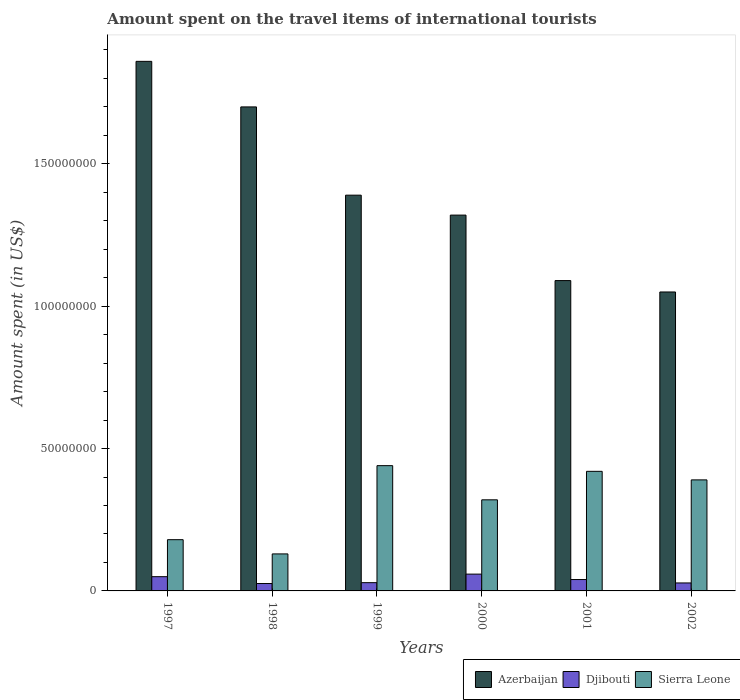How many groups of bars are there?
Your answer should be very brief. 6. How many bars are there on the 4th tick from the right?
Your answer should be very brief. 3. In how many cases, is the number of bars for a given year not equal to the number of legend labels?
Keep it short and to the point. 0. What is the amount spent on the travel items of international tourists in Sierra Leone in 1998?
Offer a terse response. 1.30e+07. Across all years, what is the maximum amount spent on the travel items of international tourists in Azerbaijan?
Offer a very short reply. 1.86e+08. Across all years, what is the minimum amount spent on the travel items of international tourists in Djibouti?
Offer a very short reply. 2.60e+06. In which year was the amount spent on the travel items of international tourists in Azerbaijan maximum?
Give a very brief answer. 1997. What is the total amount spent on the travel items of international tourists in Djibouti in the graph?
Provide a succinct answer. 2.32e+07. What is the difference between the amount spent on the travel items of international tourists in Sierra Leone in 1998 and that in 2000?
Keep it short and to the point. -1.90e+07. What is the difference between the amount spent on the travel items of international tourists in Djibouti in 2000 and the amount spent on the travel items of international tourists in Sierra Leone in 2001?
Your answer should be compact. -3.61e+07. What is the average amount spent on the travel items of international tourists in Djibouti per year?
Your answer should be compact. 3.87e+06. In the year 2002, what is the difference between the amount spent on the travel items of international tourists in Azerbaijan and amount spent on the travel items of international tourists in Djibouti?
Provide a short and direct response. 1.02e+08. What is the ratio of the amount spent on the travel items of international tourists in Djibouti in 1999 to that in 2000?
Give a very brief answer. 0.49. Is the amount spent on the travel items of international tourists in Sierra Leone in 1998 less than that in 2001?
Offer a very short reply. Yes. Is the difference between the amount spent on the travel items of international tourists in Azerbaijan in 1997 and 2000 greater than the difference between the amount spent on the travel items of international tourists in Djibouti in 1997 and 2000?
Ensure brevity in your answer.  Yes. What is the difference between the highest and the second highest amount spent on the travel items of international tourists in Azerbaijan?
Provide a short and direct response. 1.60e+07. What is the difference between the highest and the lowest amount spent on the travel items of international tourists in Azerbaijan?
Offer a terse response. 8.10e+07. In how many years, is the amount spent on the travel items of international tourists in Azerbaijan greater than the average amount spent on the travel items of international tourists in Azerbaijan taken over all years?
Your answer should be very brief. 2. Is the sum of the amount spent on the travel items of international tourists in Azerbaijan in 1998 and 2000 greater than the maximum amount spent on the travel items of international tourists in Djibouti across all years?
Provide a succinct answer. Yes. What does the 1st bar from the left in 2000 represents?
Your response must be concise. Azerbaijan. What does the 1st bar from the right in 2000 represents?
Give a very brief answer. Sierra Leone. Is it the case that in every year, the sum of the amount spent on the travel items of international tourists in Azerbaijan and amount spent on the travel items of international tourists in Djibouti is greater than the amount spent on the travel items of international tourists in Sierra Leone?
Ensure brevity in your answer.  Yes. How many bars are there?
Make the answer very short. 18. How many years are there in the graph?
Provide a succinct answer. 6. What is the difference between two consecutive major ticks on the Y-axis?
Provide a succinct answer. 5.00e+07. Are the values on the major ticks of Y-axis written in scientific E-notation?
Offer a terse response. No. Does the graph contain any zero values?
Keep it short and to the point. No. Where does the legend appear in the graph?
Provide a short and direct response. Bottom right. What is the title of the graph?
Your answer should be compact. Amount spent on the travel items of international tourists. Does "Denmark" appear as one of the legend labels in the graph?
Your response must be concise. No. What is the label or title of the X-axis?
Provide a short and direct response. Years. What is the label or title of the Y-axis?
Your answer should be compact. Amount spent (in US$). What is the Amount spent (in US$) of Azerbaijan in 1997?
Your answer should be compact. 1.86e+08. What is the Amount spent (in US$) of Djibouti in 1997?
Provide a short and direct response. 5.00e+06. What is the Amount spent (in US$) of Sierra Leone in 1997?
Keep it short and to the point. 1.80e+07. What is the Amount spent (in US$) in Azerbaijan in 1998?
Keep it short and to the point. 1.70e+08. What is the Amount spent (in US$) of Djibouti in 1998?
Your answer should be very brief. 2.60e+06. What is the Amount spent (in US$) in Sierra Leone in 1998?
Ensure brevity in your answer.  1.30e+07. What is the Amount spent (in US$) in Azerbaijan in 1999?
Provide a succinct answer. 1.39e+08. What is the Amount spent (in US$) of Djibouti in 1999?
Offer a terse response. 2.90e+06. What is the Amount spent (in US$) in Sierra Leone in 1999?
Make the answer very short. 4.40e+07. What is the Amount spent (in US$) in Azerbaijan in 2000?
Keep it short and to the point. 1.32e+08. What is the Amount spent (in US$) of Djibouti in 2000?
Provide a succinct answer. 5.90e+06. What is the Amount spent (in US$) in Sierra Leone in 2000?
Keep it short and to the point. 3.20e+07. What is the Amount spent (in US$) of Azerbaijan in 2001?
Offer a very short reply. 1.09e+08. What is the Amount spent (in US$) in Djibouti in 2001?
Make the answer very short. 4.00e+06. What is the Amount spent (in US$) of Sierra Leone in 2001?
Your answer should be very brief. 4.20e+07. What is the Amount spent (in US$) in Azerbaijan in 2002?
Provide a short and direct response. 1.05e+08. What is the Amount spent (in US$) in Djibouti in 2002?
Keep it short and to the point. 2.80e+06. What is the Amount spent (in US$) of Sierra Leone in 2002?
Provide a short and direct response. 3.90e+07. Across all years, what is the maximum Amount spent (in US$) of Azerbaijan?
Keep it short and to the point. 1.86e+08. Across all years, what is the maximum Amount spent (in US$) in Djibouti?
Ensure brevity in your answer.  5.90e+06. Across all years, what is the maximum Amount spent (in US$) in Sierra Leone?
Make the answer very short. 4.40e+07. Across all years, what is the minimum Amount spent (in US$) in Azerbaijan?
Your response must be concise. 1.05e+08. Across all years, what is the minimum Amount spent (in US$) of Djibouti?
Provide a short and direct response. 2.60e+06. Across all years, what is the minimum Amount spent (in US$) of Sierra Leone?
Make the answer very short. 1.30e+07. What is the total Amount spent (in US$) of Azerbaijan in the graph?
Make the answer very short. 8.41e+08. What is the total Amount spent (in US$) of Djibouti in the graph?
Provide a short and direct response. 2.32e+07. What is the total Amount spent (in US$) in Sierra Leone in the graph?
Keep it short and to the point. 1.88e+08. What is the difference between the Amount spent (in US$) in Azerbaijan in 1997 and that in 1998?
Give a very brief answer. 1.60e+07. What is the difference between the Amount spent (in US$) in Djibouti in 1997 and that in 1998?
Offer a terse response. 2.40e+06. What is the difference between the Amount spent (in US$) in Azerbaijan in 1997 and that in 1999?
Your response must be concise. 4.70e+07. What is the difference between the Amount spent (in US$) of Djibouti in 1997 and that in 1999?
Offer a very short reply. 2.10e+06. What is the difference between the Amount spent (in US$) in Sierra Leone in 1997 and that in 1999?
Offer a terse response. -2.60e+07. What is the difference between the Amount spent (in US$) of Azerbaijan in 1997 and that in 2000?
Offer a terse response. 5.40e+07. What is the difference between the Amount spent (in US$) in Djibouti in 1997 and that in 2000?
Provide a short and direct response. -9.00e+05. What is the difference between the Amount spent (in US$) of Sierra Leone in 1997 and that in 2000?
Your response must be concise. -1.40e+07. What is the difference between the Amount spent (in US$) in Azerbaijan in 1997 and that in 2001?
Ensure brevity in your answer.  7.70e+07. What is the difference between the Amount spent (in US$) in Djibouti in 1997 and that in 2001?
Your answer should be compact. 1.00e+06. What is the difference between the Amount spent (in US$) of Sierra Leone in 1997 and that in 2001?
Ensure brevity in your answer.  -2.40e+07. What is the difference between the Amount spent (in US$) of Azerbaijan in 1997 and that in 2002?
Provide a succinct answer. 8.10e+07. What is the difference between the Amount spent (in US$) of Djibouti in 1997 and that in 2002?
Make the answer very short. 2.20e+06. What is the difference between the Amount spent (in US$) in Sierra Leone in 1997 and that in 2002?
Keep it short and to the point. -2.10e+07. What is the difference between the Amount spent (in US$) of Azerbaijan in 1998 and that in 1999?
Your response must be concise. 3.10e+07. What is the difference between the Amount spent (in US$) in Sierra Leone in 1998 and that in 1999?
Offer a terse response. -3.10e+07. What is the difference between the Amount spent (in US$) of Azerbaijan in 1998 and that in 2000?
Make the answer very short. 3.80e+07. What is the difference between the Amount spent (in US$) of Djibouti in 1998 and that in 2000?
Provide a succinct answer. -3.30e+06. What is the difference between the Amount spent (in US$) of Sierra Leone in 1998 and that in 2000?
Make the answer very short. -1.90e+07. What is the difference between the Amount spent (in US$) of Azerbaijan in 1998 and that in 2001?
Provide a succinct answer. 6.10e+07. What is the difference between the Amount spent (in US$) in Djibouti in 1998 and that in 2001?
Your answer should be very brief. -1.40e+06. What is the difference between the Amount spent (in US$) of Sierra Leone in 1998 and that in 2001?
Give a very brief answer. -2.90e+07. What is the difference between the Amount spent (in US$) in Azerbaijan in 1998 and that in 2002?
Make the answer very short. 6.50e+07. What is the difference between the Amount spent (in US$) of Sierra Leone in 1998 and that in 2002?
Your answer should be very brief. -2.60e+07. What is the difference between the Amount spent (in US$) in Sierra Leone in 1999 and that in 2000?
Your response must be concise. 1.20e+07. What is the difference between the Amount spent (in US$) of Azerbaijan in 1999 and that in 2001?
Your answer should be compact. 3.00e+07. What is the difference between the Amount spent (in US$) in Djibouti in 1999 and that in 2001?
Your answer should be compact. -1.10e+06. What is the difference between the Amount spent (in US$) of Azerbaijan in 1999 and that in 2002?
Provide a succinct answer. 3.40e+07. What is the difference between the Amount spent (in US$) in Azerbaijan in 2000 and that in 2001?
Ensure brevity in your answer.  2.30e+07. What is the difference between the Amount spent (in US$) in Djibouti in 2000 and that in 2001?
Provide a succinct answer. 1.90e+06. What is the difference between the Amount spent (in US$) in Sierra Leone in 2000 and that in 2001?
Provide a short and direct response. -1.00e+07. What is the difference between the Amount spent (in US$) of Azerbaijan in 2000 and that in 2002?
Offer a very short reply. 2.70e+07. What is the difference between the Amount spent (in US$) in Djibouti in 2000 and that in 2002?
Your answer should be very brief. 3.10e+06. What is the difference between the Amount spent (in US$) of Sierra Leone in 2000 and that in 2002?
Give a very brief answer. -7.00e+06. What is the difference between the Amount spent (in US$) in Djibouti in 2001 and that in 2002?
Make the answer very short. 1.20e+06. What is the difference between the Amount spent (in US$) of Azerbaijan in 1997 and the Amount spent (in US$) of Djibouti in 1998?
Your response must be concise. 1.83e+08. What is the difference between the Amount spent (in US$) of Azerbaijan in 1997 and the Amount spent (in US$) of Sierra Leone in 1998?
Keep it short and to the point. 1.73e+08. What is the difference between the Amount spent (in US$) of Djibouti in 1997 and the Amount spent (in US$) of Sierra Leone in 1998?
Make the answer very short. -8.00e+06. What is the difference between the Amount spent (in US$) of Azerbaijan in 1997 and the Amount spent (in US$) of Djibouti in 1999?
Your answer should be compact. 1.83e+08. What is the difference between the Amount spent (in US$) of Azerbaijan in 1997 and the Amount spent (in US$) of Sierra Leone in 1999?
Provide a succinct answer. 1.42e+08. What is the difference between the Amount spent (in US$) in Djibouti in 1997 and the Amount spent (in US$) in Sierra Leone in 1999?
Make the answer very short. -3.90e+07. What is the difference between the Amount spent (in US$) in Azerbaijan in 1997 and the Amount spent (in US$) in Djibouti in 2000?
Your answer should be compact. 1.80e+08. What is the difference between the Amount spent (in US$) of Azerbaijan in 1997 and the Amount spent (in US$) of Sierra Leone in 2000?
Provide a short and direct response. 1.54e+08. What is the difference between the Amount spent (in US$) of Djibouti in 1997 and the Amount spent (in US$) of Sierra Leone in 2000?
Make the answer very short. -2.70e+07. What is the difference between the Amount spent (in US$) of Azerbaijan in 1997 and the Amount spent (in US$) of Djibouti in 2001?
Your answer should be compact. 1.82e+08. What is the difference between the Amount spent (in US$) of Azerbaijan in 1997 and the Amount spent (in US$) of Sierra Leone in 2001?
Give a very brief answer. 1.44e+08. What is the difference between the Amount spent (in US$) in Djibouti in 1997 and the Amount spent (in US$) in Sierra Leone in 2001?
Ensure brevity in your answer.  -3.70e+07. What is the difference between the Amount spent (in US$) of Azerbaijan in 1997 and the Amount spent (in US$) of Djibouti in 2002?
Ensure brevity in your answer.  1.83e+08. What is the difference between the Amount spent (in US$) of Azerbaijan in 1997 and the Amount spent (in US$) of Sierra Leone in 2002?
Your answer should be compact. 1.47e+08. What is the difference between the Amount spent (in US$) of Djibouti in 1997 and the Amount spent (in US$) of Sierra Leone in 2002?
Provide a succinct answer. -3.40e+07. What is the difference between the Amount spent (in US$) of Azerbaijan in 1998 and the Amount spent (in US$) of Djibouti in 1999?
Your response must be concise. 1.67e+08. What is the difference between the Amount spent (in US$) in Azerbaijan in 1998 and the Amount spent (in US$) in Sierra Leone in 1999?
Give a very brief answer. 1.26e+08. What is the difference between the Amount spent (in US$) of Djibouti in 1998 and the Amount spent (in US$) of Sierra Leone in 1999?
Provide a succinct answer. -4.14e+07. What is the difference between the Amount spent (in US$) in Azerbaijan in 1998 and the Amount spent (in US$) in Djibouti in 2000?
Keep it short and to the point. 1.64e+08. What is the difference between the Amount spent (in US$) in Azerbaijan in 1998 and the Amount spent (in US$) in Sierra Leone in 2000?
Your answer should be very brief. 1.38e+08. What is the difference between the Amount spent (in US$) in Djibouti in 1998 and the Amount spent (in US$) in Sierra Leone in 2000?
Ensure brevity in your answer.  -2.94e+07. What is the difference between the Amount spent (in US$) in Azerbaijan in 1998 and the Amount spent (in US$) in Djibouti in 2001?
Offer a very short reply. 1.66e+08. What is the difference between the Amount spent (in US$) in Azerbaijan in 1998 and the Amount spent (in US$) in Sierra Leone in 2001?
Provide a succinct answer. 1.28e+08. What is the difference between the Amount spent (in US$) in Djibouti in 1998 and the Amount spent (in US$) in Sierra Leone in 2001?
Give a very brief answer. -3.94e+07. What is the difference between the Amount spent (in US$) in Azerbaijan in 1998 and the Amount spent (in US$) in Djibouti in 2002?
Your answer should be compact. 1.67e+08. What is the difference between the Amount spent (in US$) of Azerbaijan in 1998 and the Amount spent (in US$) of Sierra Leone in 2002?
Ensure brevity in your answer.  1.31e+08. What is the difference between the Amount spent (in US$) of Djibouti in 1998 and the Amount spent (in US$) of Sierra Leone in 2002?
Offer a very short reply. -3.64e+07. What is the difference between the Amount spent (in US$) in Azerbaijan in 1999 and the Amount spent (in US$) in Djibouti in 2000?
Make the answer very short. 1.33e+08. What is the difference between the Amount spent (in US$) of Azerbaijan in 1999 and the Amount spent (in US$) of Sierra Leone in 2000?
Your answer should be compact. 1.07e+08. What is the difference between the Amount spent (in US$) of Djibouti in 1999 and the Amount spent (in US$) of Sierra Leone in 2000?
Make the answer very short. -2.91e+07. What is the difference between the Amount spent (in US$) of Azerbaijan in 1999 and the Amount spent (in US$) of Djibouti in 2001?
Keep it short and to the point. 1.35e+08. What is the difference between the Amount spent (in US$) of Azerbaijan in 1999 and the Amount spent (in US$) of Sierra Leone in 2001?
Keep it short and to the point. 9.70e+07. What is the difference between the Amount spent (in US$) in Djibouti in 1999 and the Amount spent (in US$) in Sierra Leone in 2001?
Offer a terse response. -3.91e+07. What is the difference between the Amount spent (in US$) of Azerbaijan in 1999 and the Amount spent (in US$) of Djibouti in 2002?
Provide a succinct answer. 1.36e+08. What is the difference between the Amount spent (in US$) of Djibouti in 1999 and the Amount spent (in US$) of Sierra Leone in 2002?
Ensure brevity in your answer.  -3.61e+07. What is the difference between the Amount spent (in US$) in Azerbaijan in 2000 and the Amount spent (in US$) in Djibouti in 2001?
Make the answer very short. 1.28e+08. What is the difference between the Amount spent (in US$) in Azerbaijan in 2000 and the Amount spent (in US$) in Sierra Leone in 2001?
Your answer should be very brief. 9.00e+07. What is the difference between the Amount spent (in US$) of Djibouti in 2000 and the Amount spent (in US$) of Sierra Leone in 2001?
Your response must be concise. -3.61e+07. What is the difference between the Amount spent (in US$) in Azerbaijan in 2000 and the Amount spent (in US$) in Djibouti in 2002?
Ensure brevity in your answer.  1.29e+08. What is the difference between the Amount spent (in US$) in Azerbaijan in 2000 and the Amount spent (in US$) in Sierra Leone in 2002?
Provide a short and direct response. 9.30e+07. What is the difference between the Amount spent (in US$) of Djibouti in 2000 and the Amount spent (in US$) of Sierra Leone in 2002?
Ensure brevity in your answer.  -3.31e+07. What is the difference between the Amount spent (in US$) in Azerbaijan in 2001 and the Amount spent (in US$) in Djibouti in 2002?
Give a very brief answer. 1.06e+08. What is the difference between the Amount spent (in US$) in Azerbaijan in 2001 and the Amount spent (in US$) in Sierra Leone in 2002?
Give a very brief answer. 7.00e+07. What is the difference between the Amount spent (in US$) in Djibouti in 2001 and the Amount spent (in US$) in Sierra Leone in 2002?
Ensure brevity in your answer.  -3.50e+07. What is the average Amount spent (in US$) of Azerbaijan per year?
Keep it short and to the point. 1.40e+08. What is the average Amount spent (in US$) in Djibouti per year?
Offer a very short reply. 3.87e+06. What is the average Amount spent (in US$) of Sierra Leone per year?
Provide a succinct answer. 3.13e+07. In the year 1997, what is the difference between the Amount spent (in US$) of Azerbaijan and Amount spent (in US$) of Djibouti?
Offer a very short reply. 1.81e+08. In the year 1997, what is the difference between the Amount spent (in US$) in Azerbaijan and Amount spent (in US$) in Sierra Leone?
Your answer should be compact. 1.68e+08. In the year 1997, what is the difference between the Amount spent (in US$) in Djibouti and Amount spent (in US$) in Sierra Leone?
Keep it short and to the point. -1.30e+07. In the year 1998, what is the difference between the Amount spent (in US$) of Azerbaijan and Amount spent (in US$) of Djibouti?
Provide a succinct answer. 1.67e+08. In the year 1998, what is the difference between the Amount spent (in US$) in Azerbaijan and Amount spent (in US$) in Sierra Leone?
Your answer should be very brief. 1.57e+08. In the year 1998, what is the difference between the Amount spent (in US$) of Djibouti and Amount spent (in US$) of Sierra Leone?
Your answer should be compact. -1.04e+07. In the year 1999, what is the difference between the Amount spent (in US$) of Azerbaijan and Amount spent (in US$) of Djibouti?
Your answer should be compact. 1.36e+08. In the year 1999, what is the difference between the Amount spent (in US$) in Azerbaijan and Amount spent (in US$) in Sierra Leone?
Ensure brevity in your answer.  9.50e+07. In the year 1999, what is the difference between the Amount spent (in US$) in Djibouti and Amount spent (in US$) in Sierra Leone?
Provide a short and direct response. -4.11e+07. In the year 2000, what is the difference between the Amount spent (in US$) in Azerbaijan and Amount spent (in US$) in Djibouti?
Your answer should be very brief. 1.26e+08. In the year 2000, what is the difference between the Amount spent (in US$) of Azerbaijan and Amount spent (in US$) of Sierra Leone?
Your answer should be compact. 1.00e+08. In the year 2000, what is the difference between the Amount spent (in US$) in Djibouti and Amount spent (in US$) in Sierra Leone?
Provide a short and direct response. -2.61e+07. In the year 2001, what is the difference between the Amount spent (in US$) in Azerbaijan and Amount spent (in US$) in Djibouti?
Your answer should be very brief. 1.05e+08. In the year 2001, what is the difference between the Amount spent (in US$) in Azerbaijan and Amount spent (in US$) in Sierra Leone?
Provide a succinct answer. 6.70e+07. In the year 2001, what is the difference between the Amount spent (in US$) in Djibouti and Amount spent (in US$) in Sierra Leone?
Give a very brief answer. -3.80e+07. In the year 2002, what is the difference between the Amount spent (in US$) of Azerbaijan and Amount spent (in US$) of Djibouti?
Offer a very short reply. 1.02e+08. In the year 2002, what is the difference between the Amount spent (in US$) in Azerbaijan and Amount spent (in US$) in Sierra Leone?
Provide a short and direct response. 6.60e+07. In the year 2002, what is the difference between the Amount spent (in US$) of Djibouti and Amount spent (in US$) of Sierra Leone?
Ensure brevity in your answer.  -3.62e+07. What is the ratio of the Amount spent (in US$) in Azerbaijan in 1997 to that in 1998?
Provide a succinct answer. 1.09. What is the ratio of the Amount spent (in US$) in Djibouti in 1997 to that in 1998?
Your answer should be compact. 1.92. What is the ratio of the Amount spent (in US$) in Sierra Leone in 1997 to that in 1998?
Your answer should be compact. 1.38. What is the ratio of the Amount spent (in US$) in Azerbaijan in 1997 to that in 1999?
Keep it short and to the point. 1.34. What is the ratio of the Amount spent (in US$) in Djibouti in 1997 to that in 1999?
Ensure brevity in your answer.  1.72. What is the ratio of the Amount spent (in US$) of Sierra Leone in 1997 to that in 1999?
Give a very brief answer. 0.41. What is the ratio of the Amount spent (in US$) in Azerbaijan in 1997 to that in 2000?
Your answer should be compact. 1.41. What is the ratio of the Amount spent (in US$) of Djibouti in 1997 to that in 2000?
Offer a very short reply. 0.85. What is the ratio of the Amount spent (in US$) of Sierra Leone in 1997 to that in 2000?
Provide a short and direct response. 0.56. What is the ratio of the Amount spent (in US$) of Azerbaijan in 1997 to that in 2001?
Provide a short and direct response. 1.71. What is the ratio of the Amount spent (in US$) of Sierra Leone in 1997 to that in 2001?
Offer a terse response. 0.43. What is the ratio of the Amount spent (in US$) of Azerbaijan in 1997 to that in 2002?
Offer a terse response. 1.77. What is the ratio of the Amount spent (in US$) in Djibouti in 1997 to that in 2002?
Your answer should be very brief. 1.79. What is the ratio of the Amount spent (in US$) of Sierra Leone in 1997 to that in 2002?
Ensure brevity in your answer.  0.46. What is the ratio of the Amount spent (in US$) of Azerbaijan in 1998 to that in 1999?
Offer a terse response. 1.22. What is the ratio of the Amount spent (in US$) in Djibouti in 1998 to that in 1999?
Your answer should be compact. 0.9. What is the ratio of the Amount spent (in US$) of Sierra Leone in 1998 to that in 1999?
Keep it short and to the point. 0.3. What is the ratio of the Amount spent (in US$) in Azerbaijan in 1998 to that in 2000?
Offer a very short reply. 1.29. What is the ratio of the Amount spent (in US$) of Djibouti in 1998 to that in 2000?
Ensure brevity in your answer.  0.44. What is the ratio of the Amount spent (in US$) of Sierra Leone in 1998 to that in 2000?
Offer a very short reply. 0.41. What is the ratio of the Amount spent (in US$) in Azerbaijan in 1998 to that in 2001?
Give a very brief answer. 1.56. What is the ratio of the Amount spent (in US$) of Djibouti in 1998 to that in 2001?
Your answer should be compact. 0.65. What is the ratio of the Amount spent (in US$) of Sierra Leone in 1998 to that in 2001?
Your answer should be very brief. 0.31. What is the ratio of the Amount spent (in US$) of Azerbaijan in 1998 to that in 2002?
Your response must be concise. 1.62. What is the ratio of the Amount spent (in US$) of Djibouti in 1998 to that in 2002?
Your answer should be very brief. 0.93. What is the ratio of the Amount spent (in US$) of Azerbaijan in 1999 to that in 2000?
Your answer should be compact. 1.05. What is the ratio of the Amount spent (in US$) in Djibouti in 1999 to that in 2000?
Offer a very short reply. 0.49. What is the ratio of the Amount spent (in US$) in Sierra Leone in 1999 to that in 2000?
Offer a terse response. 1.38. What is the ratio of the Amount spent (in US$) in Azerbaijan in 1999 to that in 2001?
Ensure brevity in your answer.  1.28. What is the ratio of the Amount spent (in US$) of Djibouti in 1999 to that in 2001?
Your response must be concise. 0.72. What is the ratio of the Amount spent (in US$) in Sierra Leone in 1999 to that in 2001?
Your response must be concise. 1.05. What is the ratio of the Amount spent (in US$) of Azerbaijan in 1999 to that in 2002?
Keep it short and to the point. 1.32. What is the ratio of the Amount spent (in US$) of Djibouti in 1999 to that in 2002?
Make the answer very short. 1.04. What is the ratio of the Amount spent (in US$) of Sierra Leone in 1999 to that in 2002?
Offer a very short reply. 1.13. What is the ratio of the Amount spent (in US$) of Azerbaijan in 2000 to that in 2001?
Offer a terse response. 1.21. What is the ratio of the Amount spent (in US$) of Djibouti in 2000 to that in 2001?
Give a very brief answer. 1.48. What is the ratio of the Amount spent (in US$) of Sierra Leone in 2000 to that in 2001?
Provide a short and direct response. 0.76. What is the ratio of the Amount spent (in US$) in Azerbaijan in 2000 to that in 2002?
Ensure brevity in your answer.  1.26. What is the ratio of the Amount spent (in US$) in Djibouti in 2000 to that in 2002?
Keep it short and to the point. 2.11. What is the ratio of the Amount spent (in US$) in Sierra Leone in 2000 to that in 2002?
Your response must be concise. 0.82. What is the ratio of the Amount spent (in US$) of Azerbaijan in 2001 to that in 2002?
Keep it short and to the point. 1.04. What is the ratio of the Amount spent (in US$) of Djibouti in 2001 to that in 2002?
Your answer should be very brief. 1.43. What is the ratio of the Amount spent (in US$) of Sierra Leone in 2001 to that in 2002?
Your answer should be compact. 1.08. What is the difference between the highest and the second highest Amount spent (in US$) in Azerbaijan?
Make the answer very short. 1.60e+07. What is the difference between the highest and the lowest Amount spent (in US$) of Azerbaijan?
Give a very brief answer. 8.10e+07. What is the difference between the highest and the lowest Amount spent (in US$) of Djibouti?
Provide a short and direct response. 3.30e+06. What is the difference between the highest and the lowest Amount spent (in US$) in Sierra Leone?
Your response must be concise. 3.10e+07. 